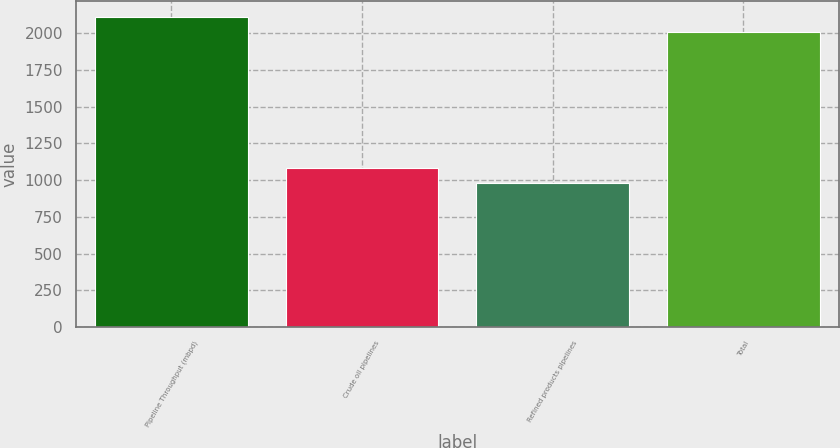Convert chart. <chart><loc_0><loc_0><loc_500><loc_500><bar_chart><fcel>Pipeline Throughput (mbpd)<fcel>Crude oil pipelines<fcel>Refined products pipelines<fcel>Total<nl><fcel>2112.2<fcel>1083.2<fcel>980<fcel>2009<nl></chart> 